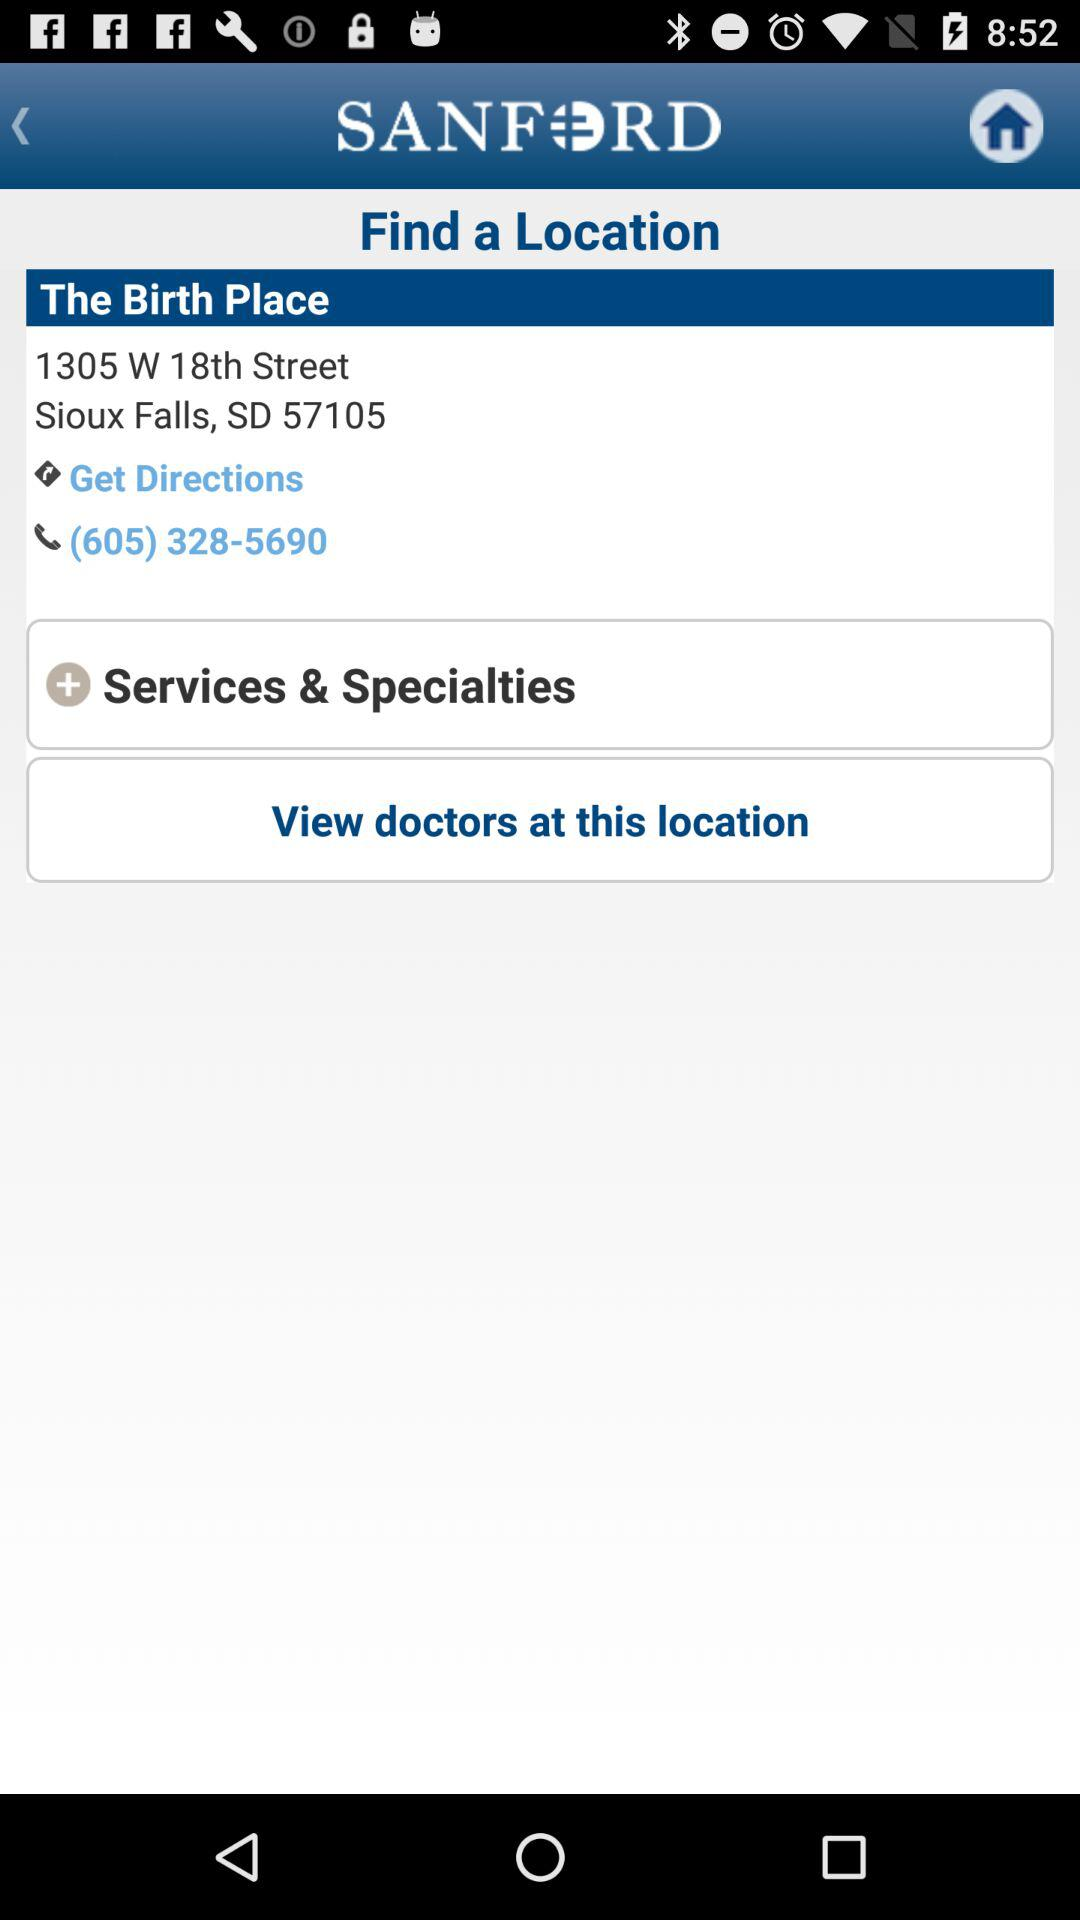What is the phone number? The phone number is (605) 328-5690. 